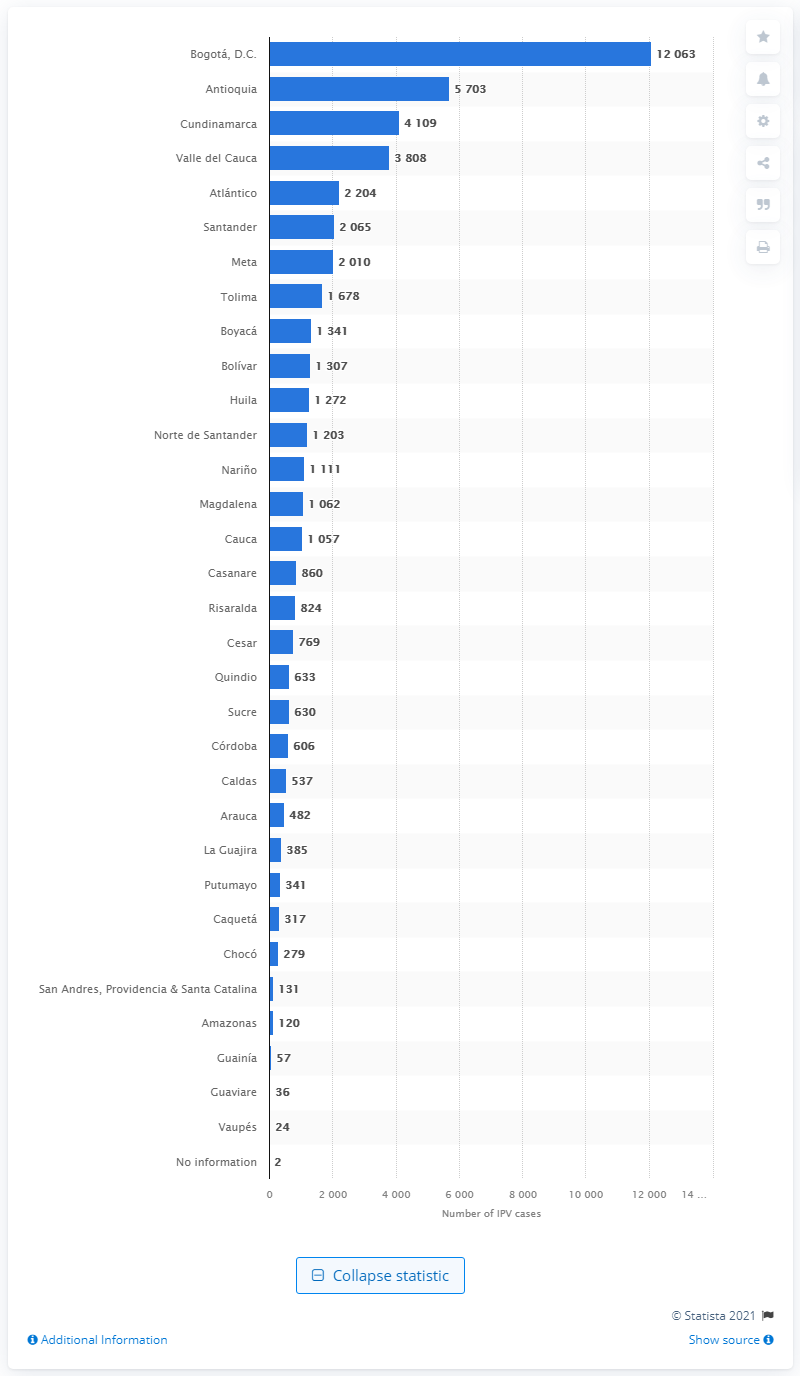Give some essential details in this illustration. In 2019, a total of 12,063 cases of intimate partner violence were registered in Bogota, D.C. 